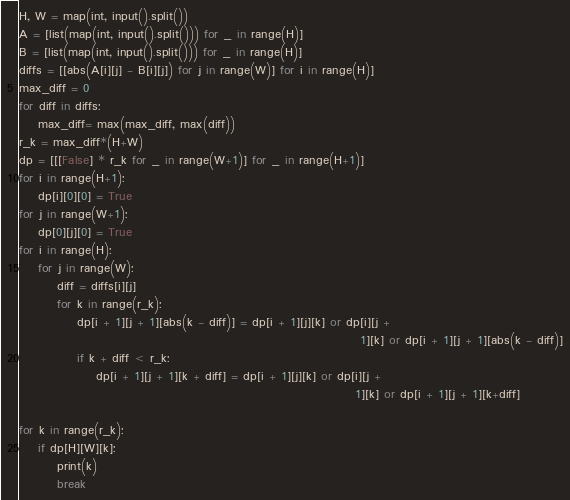<code> <loc_0><loc_0><loc_500><loc_500><_Python_>H, W = map(int, input().split())
A = [list(map(int, input().split())) for _ in range(H)]
B = [list(map(int, input().split())) for _ in range(H)]
diffs = [[abs(A[i][j] - B[i][j]) for j in range(W)] for i in range(H)]
max_diff = 0
for diff in diffs:
    max_diff= max(max_diff, max(diff))
r_k = max_diff*(H+W)
dp = [[[False] * r_k for _ in range(W+1)] for _ in range(H+1)]
for i in range(H+1):
    dp[i][0][0] = True
for j in range(W+1):
    dp[0][j][0] = True
for i in range(H):
    for j in range(W):
        diff = diffs[i][j]
        for k in range(r_k):
            dp[i + 1][j + 1][abs(k - diff)] = dp[i + 1][j][k] or dp[i][j +
                                                                       1][k] or dp[i + 1][j + 1][abs(k - diff)]
            if k + diff < r_k:
                dp[i + 1][j + 1][k + diff] = dp[i + 1][j][k] or dp[i][j +
                                                                      1][k] or dp[i + 1][j + 1][k+diff]

for k in range(r_k):
    if dp[H][W][k]:
        print(k)
        break
</code> 